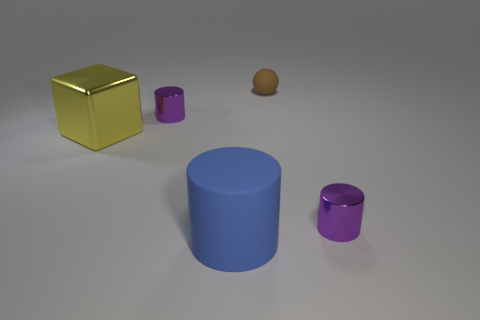Subtract all brown blocks. How many purple cylinders are left? 2 Subtract all tiny cylinders. How many cylinders are left? 1 Add 2 large green cubes. How many objects exist? 7 Subtract all balls. How many objects are left? 4 Add 2 large purple objects. How many large purple objects exist? 2 Subtract 0 green blocks. How many objects are left? 5 Subtract all big things. Subtract all rubber spheres. How many objects are left? 2 Add 5 spheres. How many spheres are left? 6 